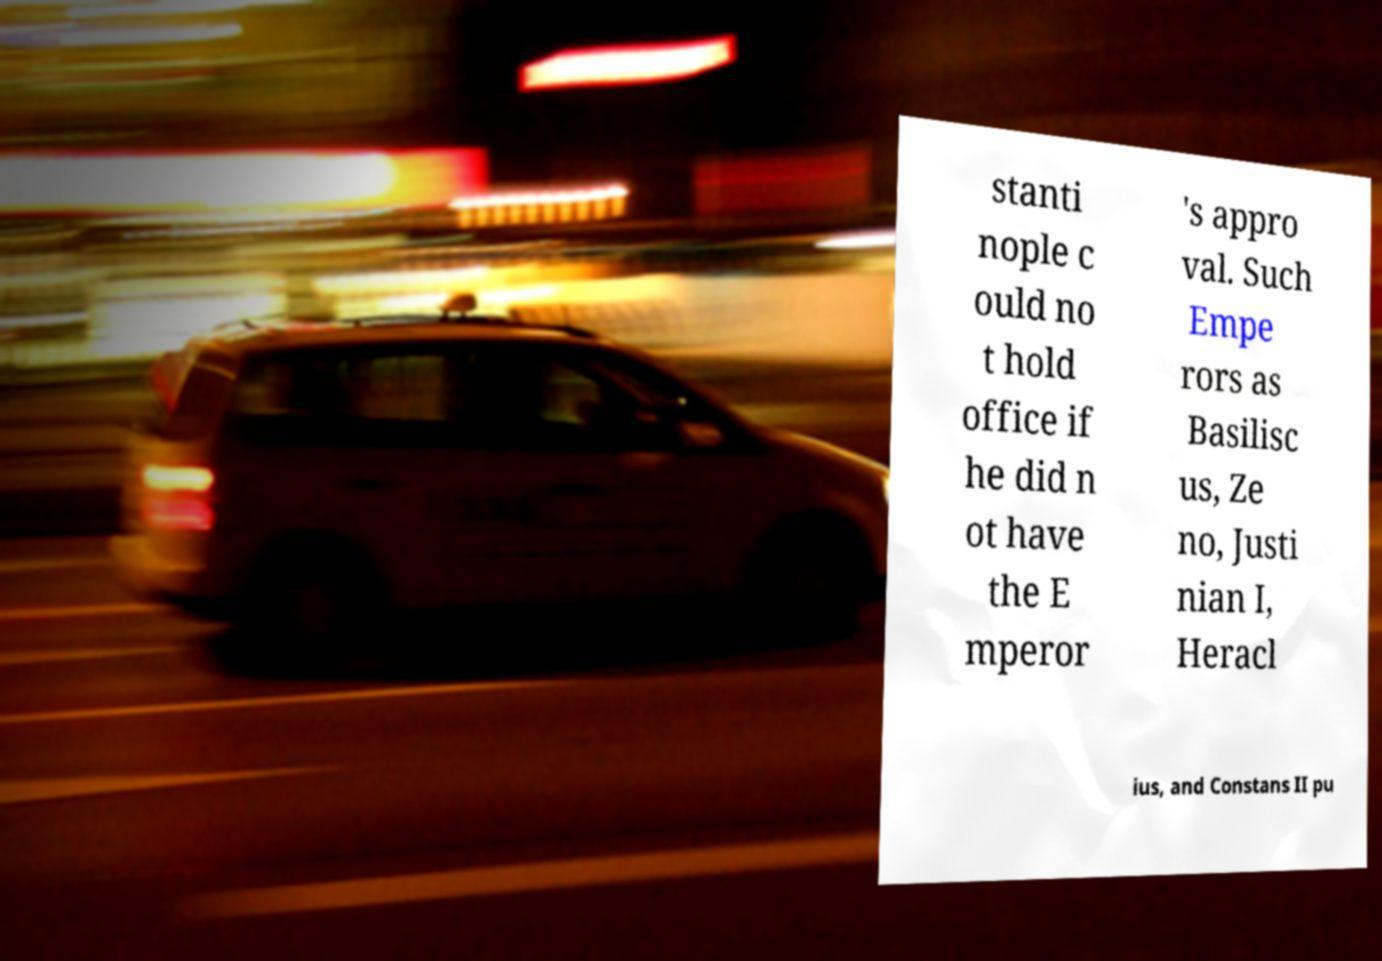Please read and relay the text visible in this image. What does it say? stanti nople c ould no t hold office if he did n ot have the E mperor 's appro val. Such Empe rors as Basilisc us, Ze no, Justi nian I, Heracl ius, and Constans II pu 